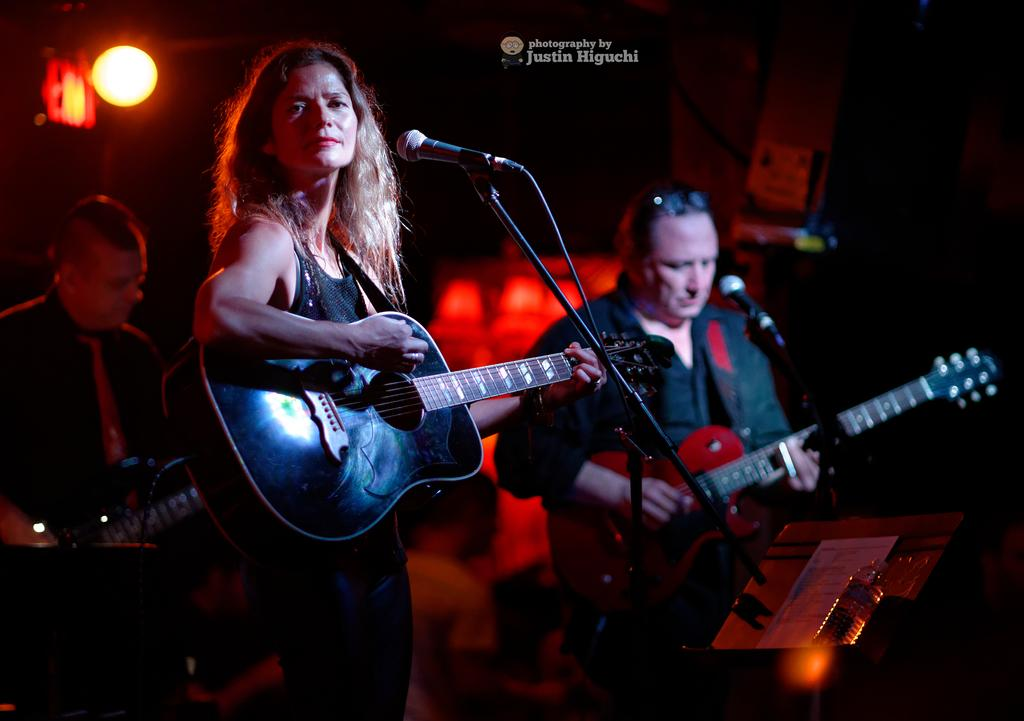What are the two persons in the image doing? The two persons in the image are playing guitar. What object can be seen in front of the guitar players? The guitar players are in front of a microphone. Can you describe the person in the background? There is another person in the background, but no specific details are provided about them. What type of scent can be smelled coming from the guitar strings in the image? There is no mention of any scent in the image, and the guitar strings do not produce a scent. 